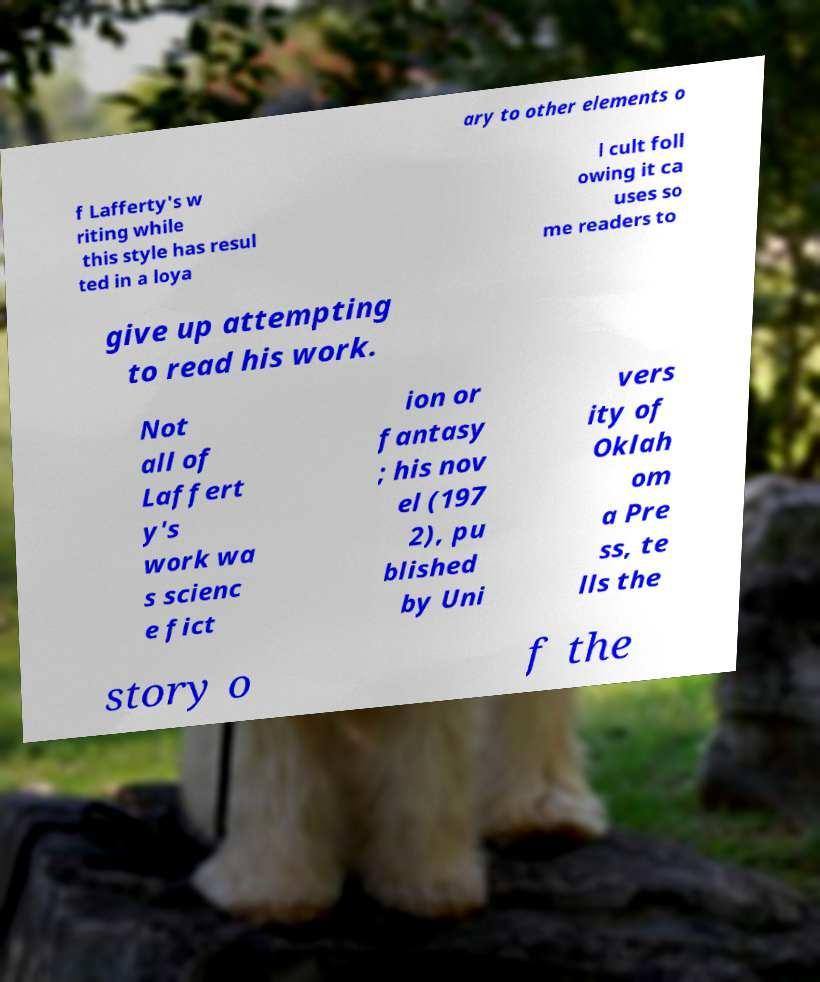For documentation purposes, I need the text within this image transcribed. Could you provide that? ary to other elements o f Lafferty's w riting while this style has resul ted in a loya l cult foll owing it ca uses so me readers to give up attempting to read his work. Not all of Laffert y's work wa s scienc e fict ion or fantasy ; his nov el (197 2), pu blished by Uni vers ity of Oklah om a Pre ss, te lls the story o f the 